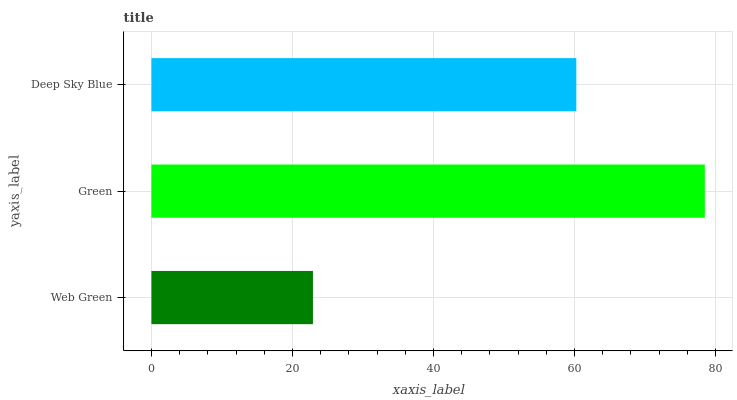Is Web Green the minimum?
Answer yes or no. Yes. Is Green the maximum?
Answer yes or no. Yes. Is Deep Sky Blue the minimum?
Answer yes or no. No. Is Deep Sky Blue the maximum?
Answer yes or no. No. Is Green greater than Deep Sky Blue?
Answer yes or no. Yes. Is Deep Sky Blue less than Green?
Answer yes or no. Yes. Is Deep Sky Blue greater than Green?
Answer yes or no. No. Is Green less than Deep Sky Blue?
Answer yes or no. No. Is Deep Sky Blue the high median?
Answer yes or no. Yes. Is Deep Sky Blue the low median?
Answer yes or no. Yes. Is Green the high median?
Answer yes or no. No. Is Green the low median?
Answer yes or no. No. 